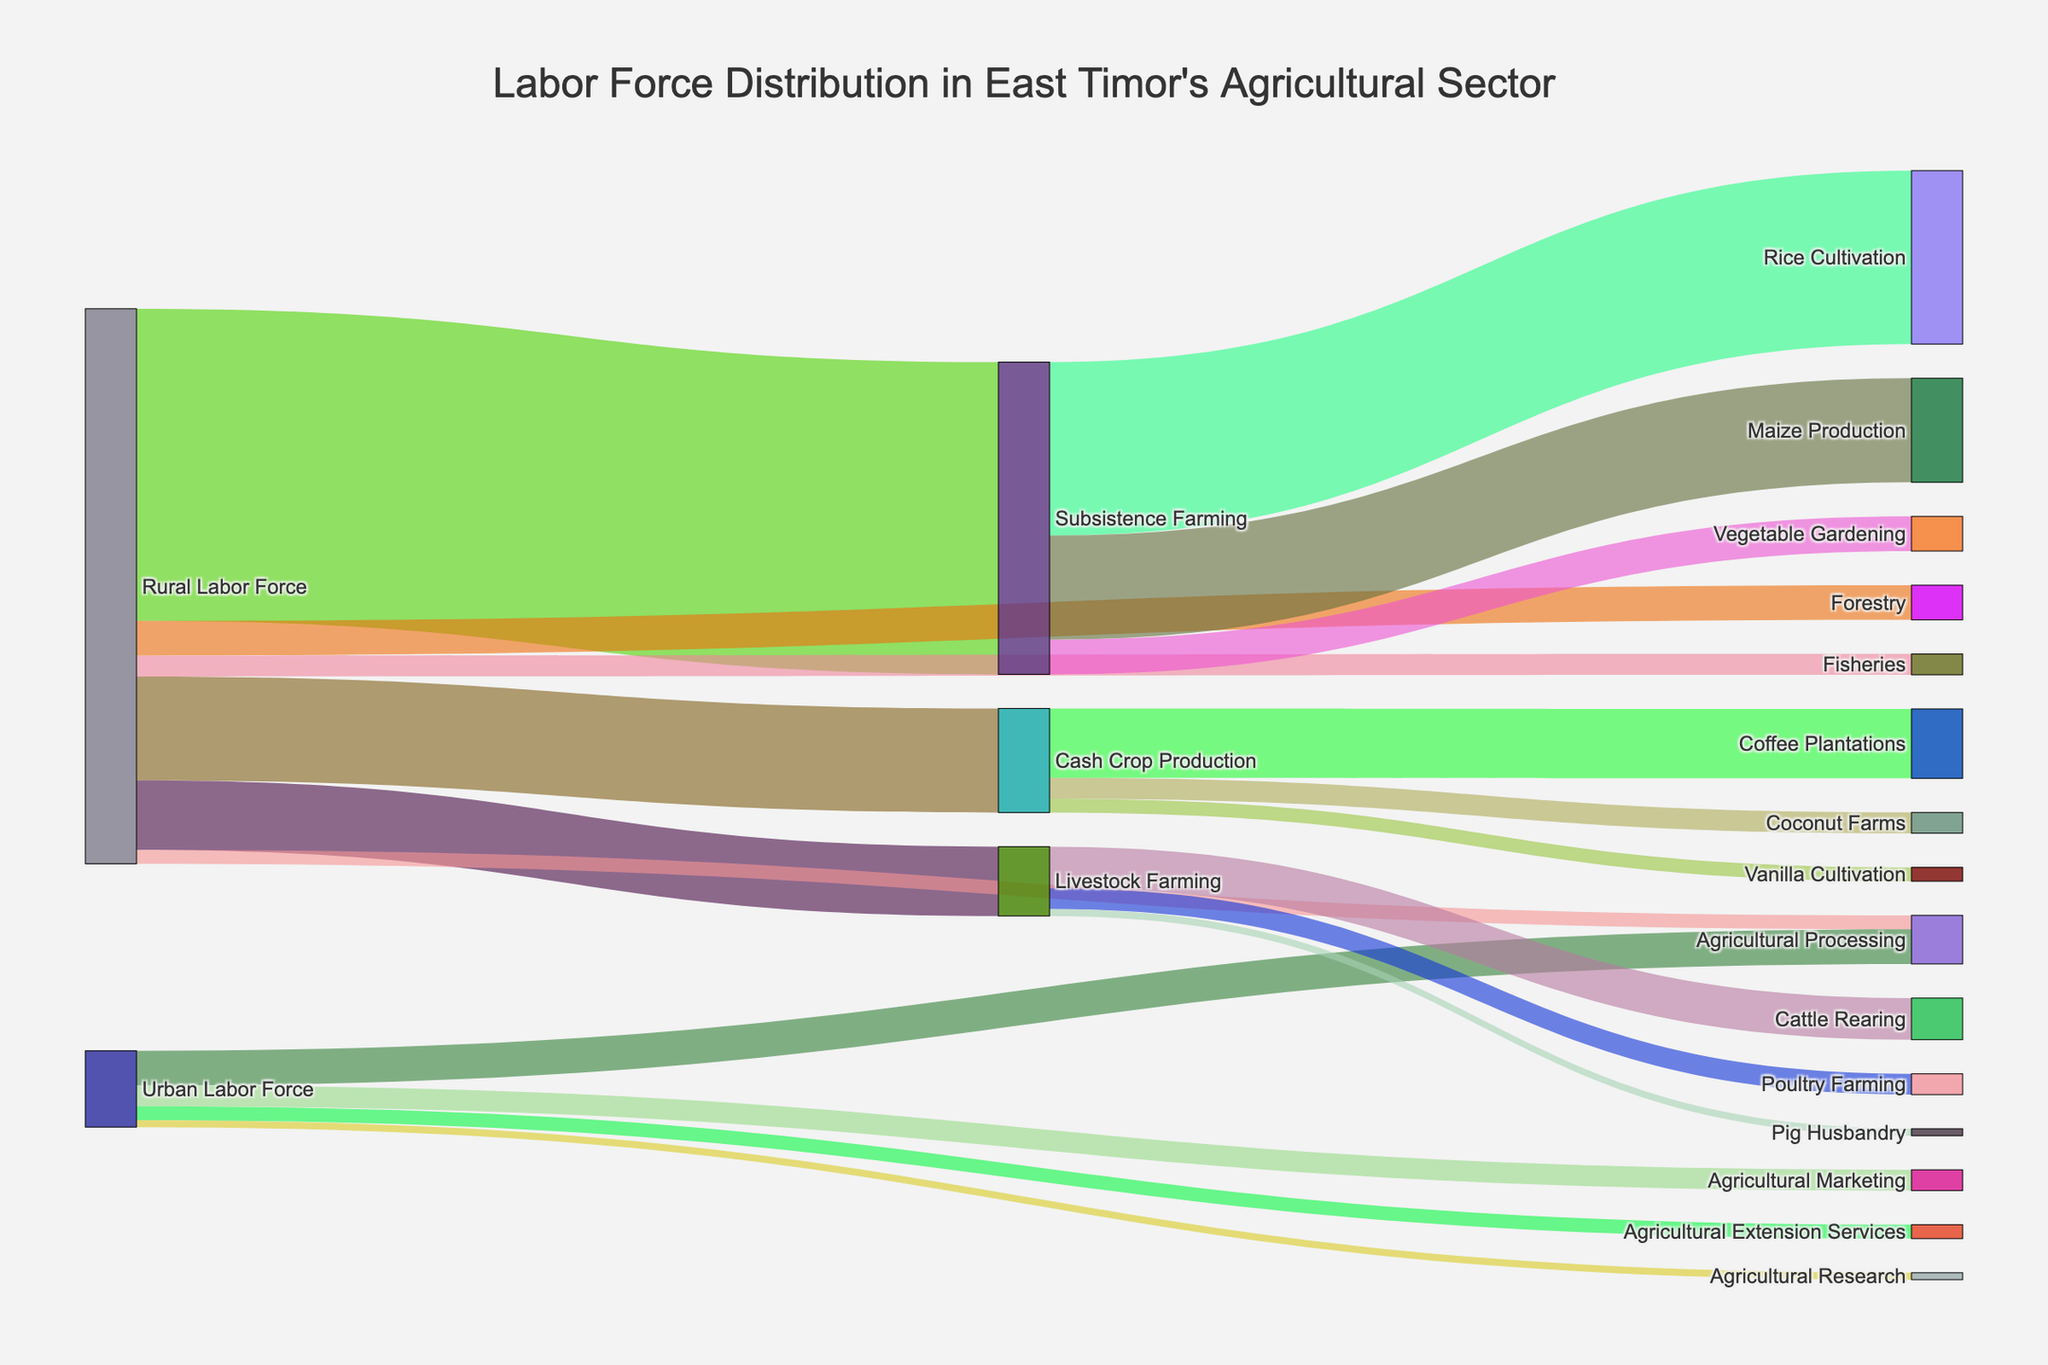What is the total number of people in the Rural Labor Force depicted in the diagram? Sum each value for their respective target categories: Subsistence Farming (45000), Cash Crop Production (15000), Livestock Farming (10000), Forestry (5000), Fisheries (3000), Agricultural Processing (2000). Therefore, the total is 45000 + 15000 + 10000 + 5000 + 3000 + 2000 = 80000.
Answer: 80000 What category in the Rural Labor Force employs the most people? Look at the values connected to Rural Labor Force and select the highest. Subsistence Farming has 45000, which is the highest.
Answer: Subsistence Farming What is the combined employment in Coffee Plantations and Coconut Farms under Cash Crop Production? Sum both values linked to Cash Crop Production: Coffee Plantations (10000) and Coconut Farms (3000), i.e., 10000 + 3000.
Answer: 13000 How does the number of people in Livestock Farming compare to that in Cash Crop Production in the Rural Labor Force? Compare the values connected to Rural Labor Force: Livestock Farming (10000) and Cash Crop Production (15000). 10000 is less than 15000.
Answer: Livestock Farming has fewer people What is the total employment in Urban Labor Force related to Agricultural Processing? Include agricultural processing values from both Rural (2000) and Urban (5000): 2000 + 5000 = 7000.
Answer: 7000 Between Agricultural Marketing and Agricultural Extension Services in Urban Labor Force, which employs more people? Compare values for Agricultural Marketing (3000) and Agricultural Extension Services (2000). 3000 is greater.
Answer: Agricultural Marketing What is the ratio of people in Subsistence Farming to those in Cash Crop Production within the Rural Labor Force? Calculate the division: 45000 (Subsistence Farming) / 15000 (Cash Crop Production) = 3.
Answer: 3:1 Which category has the least employment under the Rural Labor Force? Compare all categories under Rural Labor Force: Subsistence Farming (45000), Cash Crop Production (15000), Livestock Farming (10000), Forestry (5000), Fisheries (3000), Agricultural Processing (2000). Agricultural Processing has the least.
Answer: Agricultural Processing What is the difference in the number of people between Subsistence Farming's Rice Cultivation and Maize Production? Subtract the values: Rice Cultivation (25000) - Maize Production (15000) = 10000.
Answer: 10000 How many people in total are engaged in different types of Livestock Farming? Sum all values under Livestock Farming: Cattle Rearing (6000), Poultry Farming (3000), Pig Husbandry (1000). Thus, 6000 + 3000 + 1000.
Answer: 10000 